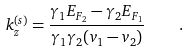Convert formula to latex. <formula><loc_0><loc_0><loc_500><loc_500>k _ { z } ^ { ( s ) } = \frac { \gamma _ { 1 } E _ { F _ { 2 } } - \gamma _ { 2 } E _ { F _ { 1 } } } { \gamma _ { 1 } \gamma _ { 2 } ( v _ { 1 } - v _ { 2 } ) } \quad .</formula> 